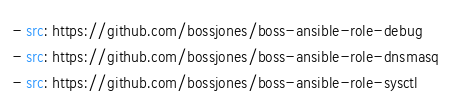Convert code to text. <code><loc_0><loc_0><loc_500><loc_500><_YAML_>- src: https://github.com/bossjones/boss-ansible-role-debug
- src: https://github.com/bossjones/boss-ansible-role-dnsmasq
- src: https://github.com/bossjones/boss-ansible-role-sysctl
</code> 